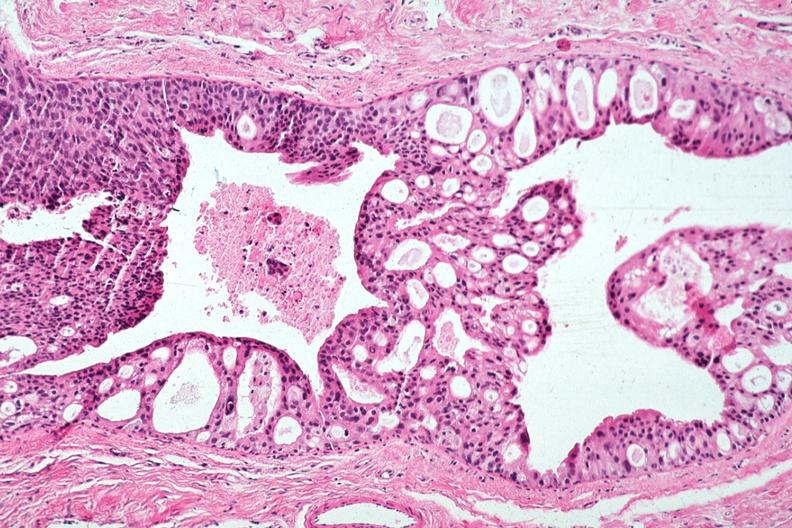s adenocarcinoma present?
Answer the question using a single word or phrase. No 